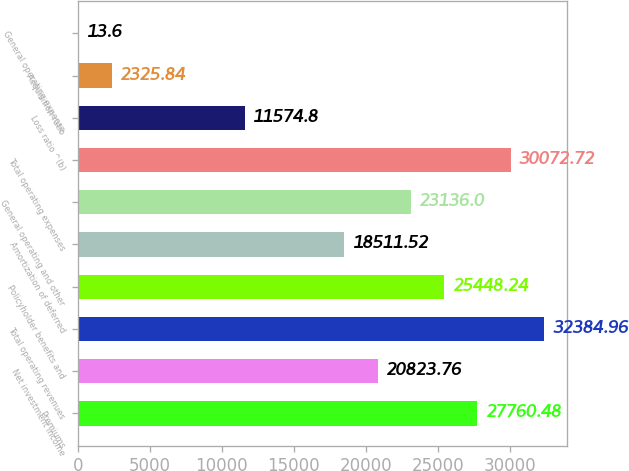Convert chart. <chart><loc_0><loc_0><loc_500><loc_500><bar_chart><fcel>Premiums<fcel>Net investment income<fcel>Total operating revenues<fcel>Policyholder benefits and<fcel>Amortization of deferred<fcel>General operating and other<fcel>Total operating expenses<fcel>Loss ratio ^(b)<fcel>Acquisition ratio<fcel>General operating expense<nl><fcel>27760.5<fcel>20823.8<fcel>32385<fcel>25448.2<fcel>18511.5<fcel>23136<fcel>30072.7<fcel>11574.8<fcel>2325.84<fcel>13.6<nl></chart> 